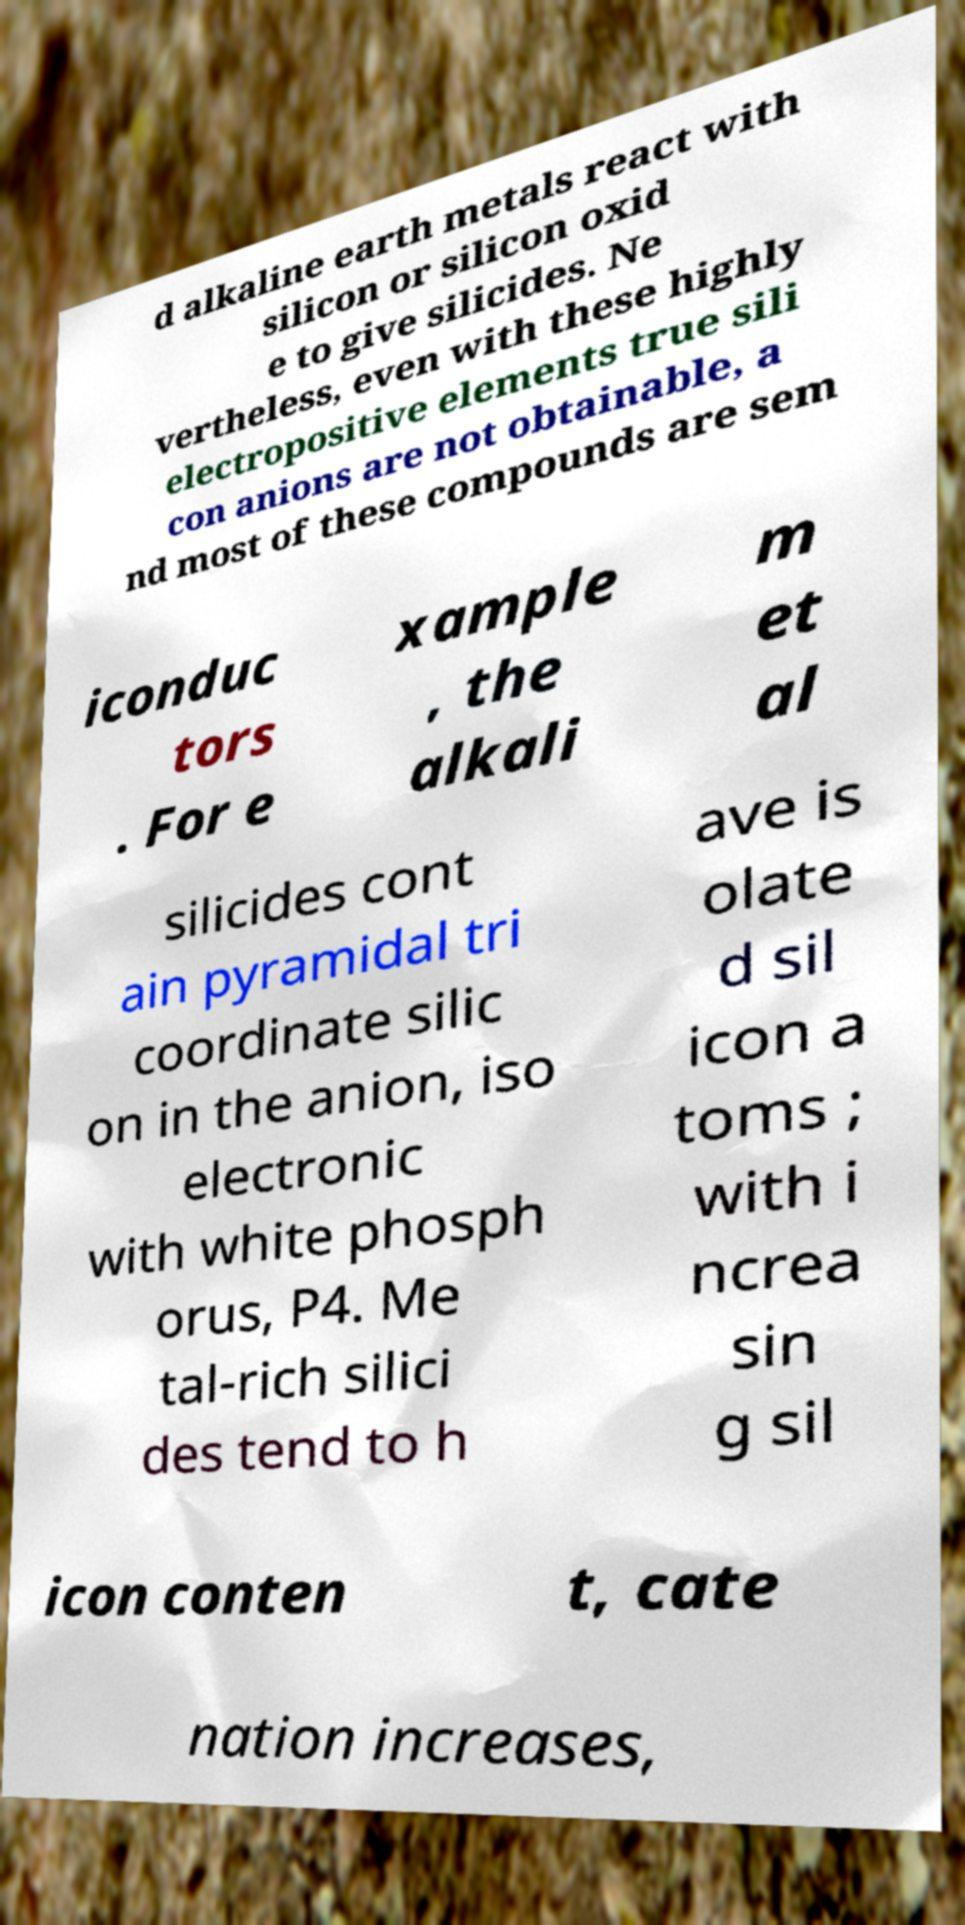Could you extract and type out the text from this image? d alkaline earth metals react with silicon or silicon oxid e to give silicides. Ne vertheless, even with these highly electropositive elements true sili con anions are not obtainable, a nd most of these compounds are sem iconduc tors . For e xample , the alkali m et al silicides cont ain pyramidal tri coordinate silic on in the anion, iso electronic with white phosph orus, P4. Me tal-rich silici des tend to h ave is olate d sil icon a toms ; with i ncrea sin g sil icon conten t, cate nation increases, 